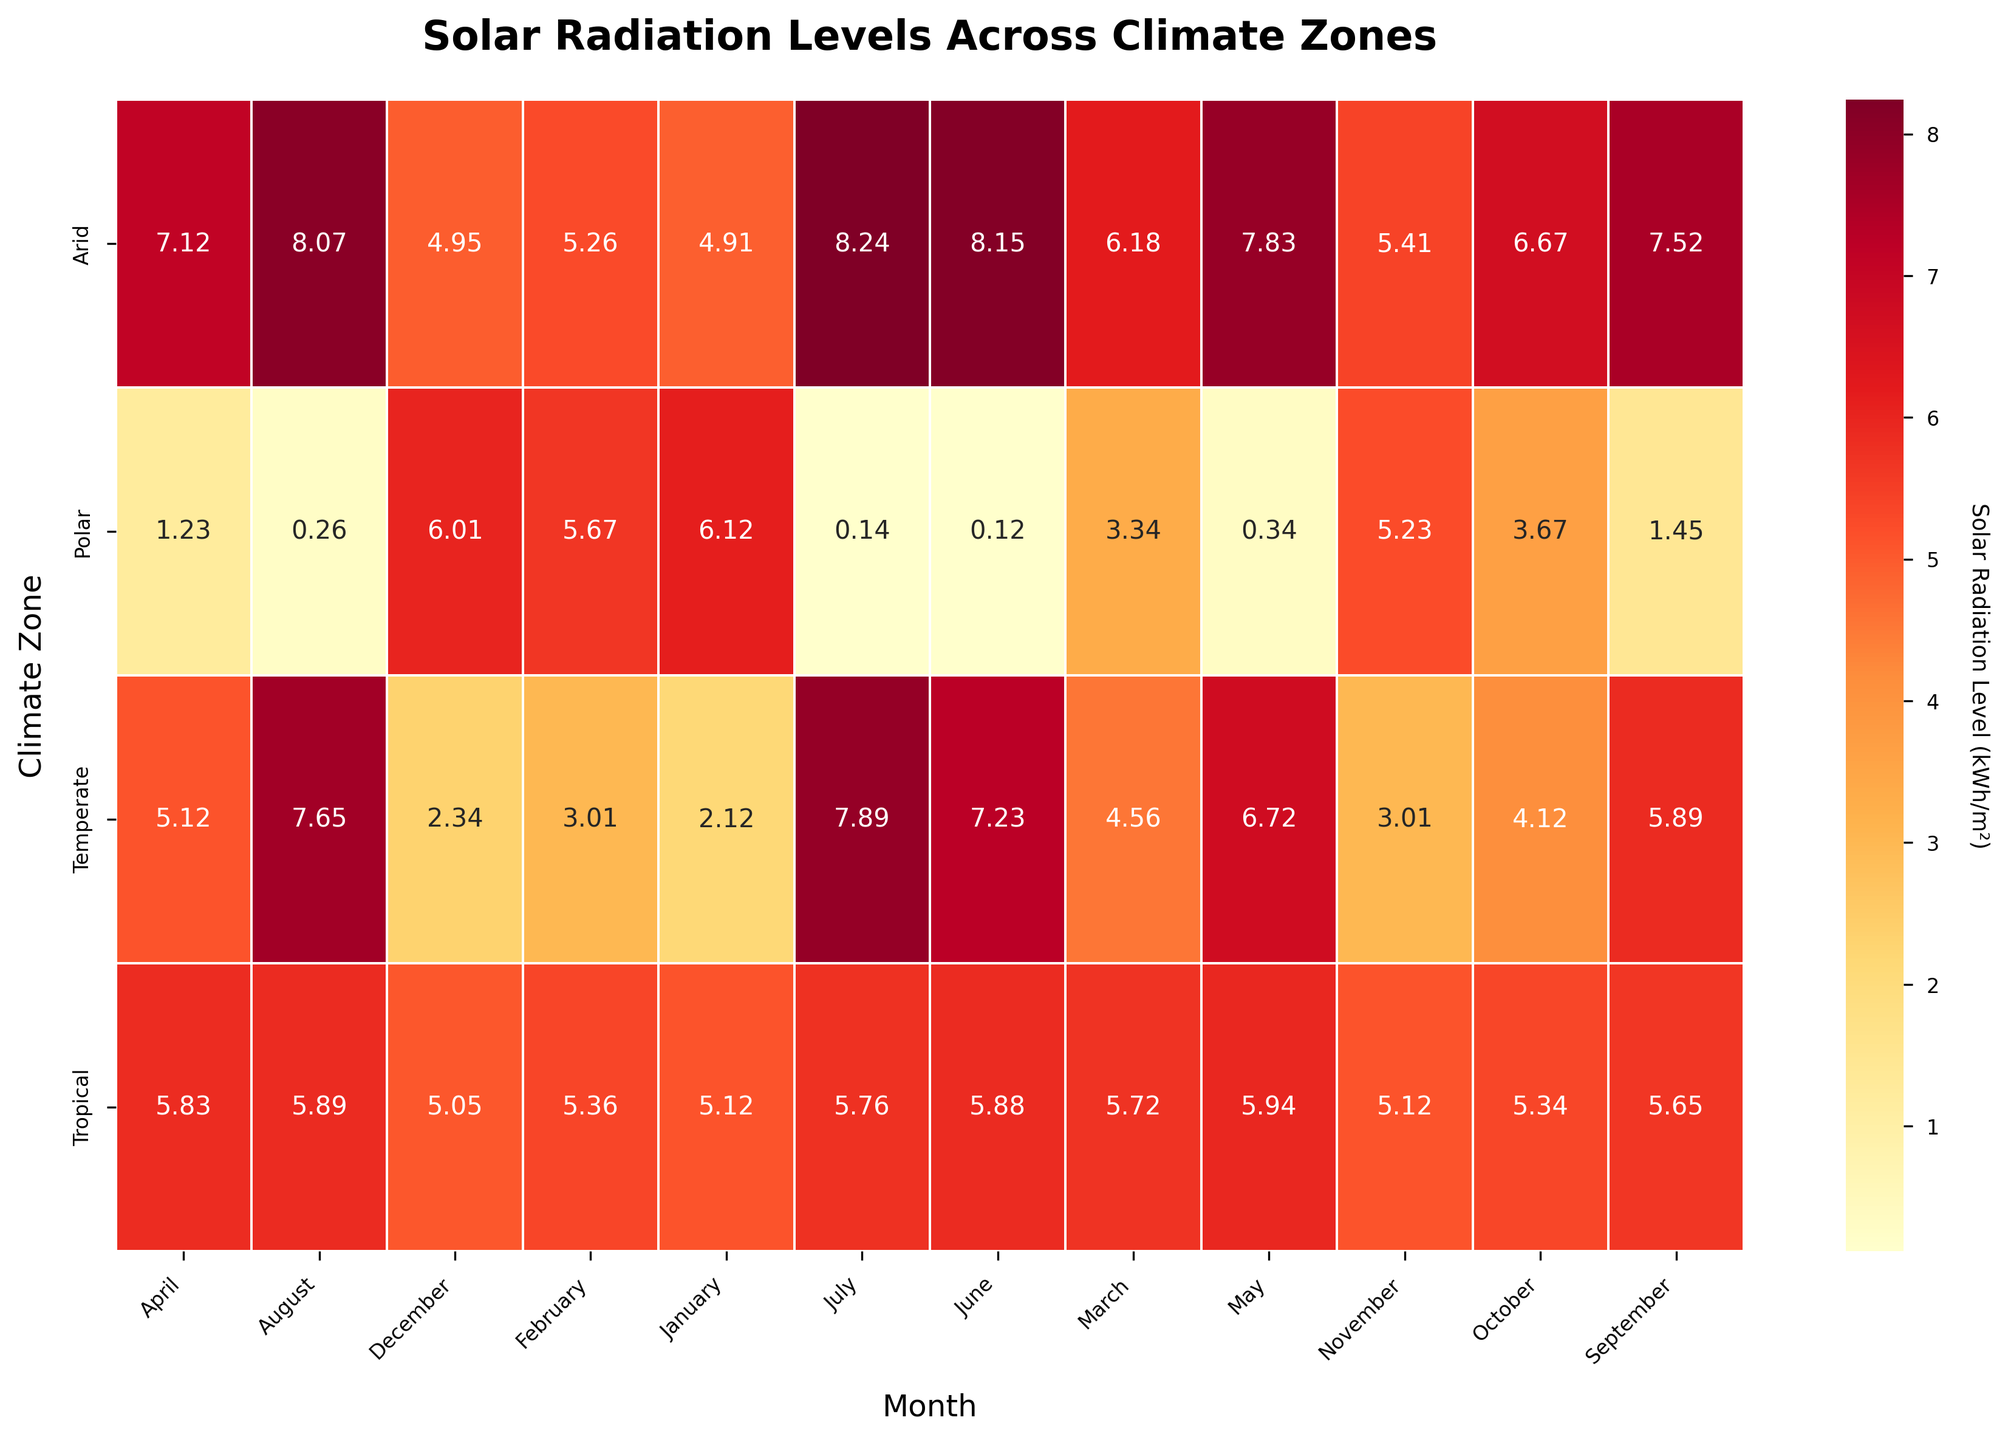What's the title of the heatmap? The title is displayed at the top of the plot in bold text and describes the main subject matter graphed in the heatmap. It can help viewers quickly understand what the graphic represents. The title is "Solar Radiation Levels Across Climate Zones".
Answer: Solar Radiation Levels Across Climate Zones Which month has the highest solar radiation level in the Arid climate zone? To determine the highest solar radiation level in the Arid climate zone, look at the row corresponding to 'Arid' and identify the highest value in that row. The highest value is in July, which is 8.24 kWh/m².
Answer: July What is the average solar radiation level for Singapore in the Tropical climate zone for the entire year? Calculate the average by summing up the monthly values for Singapore and dividing by 12. The values are: 5.12, 5.36, 5.72, 5.83, 5.94, 5.88, 5.76, 5.89, 5.65, 5.34, 5.12, 5.05. The sum is 66.56, so the average is 66.56 / 12.
Answer: 5.55 Which climate zone shows the most variability in solar radiation levels throughout the year? To identify the zone with most variability, look for the zone where the difference between the highest and lowest values is the greatest. Polar climate zone has values ranging from 0.12 to 6.12, indicating the most variability.
Answer: Polar In which month does New York (Temperate climate zone) experience the lowest solar radiation level? Check the row for 'Temperate' (New York) and find the lowest value. This occurs in January with a value of 2.12 kWh/m².
Answer: January Compare the average annual solar radiation levels of the Arid and Polar climate zones. Which one is higher? Calculate the average for both zones: Arid (4.91, 5.26, 6.18, 7.12, 7.83, 8.15, 8.24, 8.07, 7.52, 6.67, 5.41, 4.95) = 80.31 / 12 = 6.69. Polar (6.12, 5.67, 3.34, 1.23, 0.34, 0.12, 0.14, 0.26, 1.45, 3.67, 5.23, 6.01) = 33.58 / 12 = 2.80. Arid has a higher average.
Answer: Arid What is the range of solar radiation levels for the Tropical climate zone? Range is calculated as the difference between the highest and lowest values in the Tropical zone. The highest is 5.94 kWh/m² (May) and the lowest is 5.05 kWh/m² (December). 5.94 - 5.05 = 0.89.
Answer: 0.89 How does the solar radiation in the Polar climate zone change from June to December? Observe the values in the row for the Polar zone from June to December: 0.12 (June), 0.14 (July), 0.26 (August), 1.45 (September), 3.67 (October), 5.23 (November), and 6.01 (December). This shows a gradually increasing trend.
Answer: Increasing Which climate zone has the second-highest solar radiation level in October? Identify the maximum values for October across all zones and find the second highest. The values are Tropical (5.34), Arid (6.67), Temperate (4.12), Polar (3.67). The second highest is Tropical with 5.34 kWh/m².
Answer: Tropical 